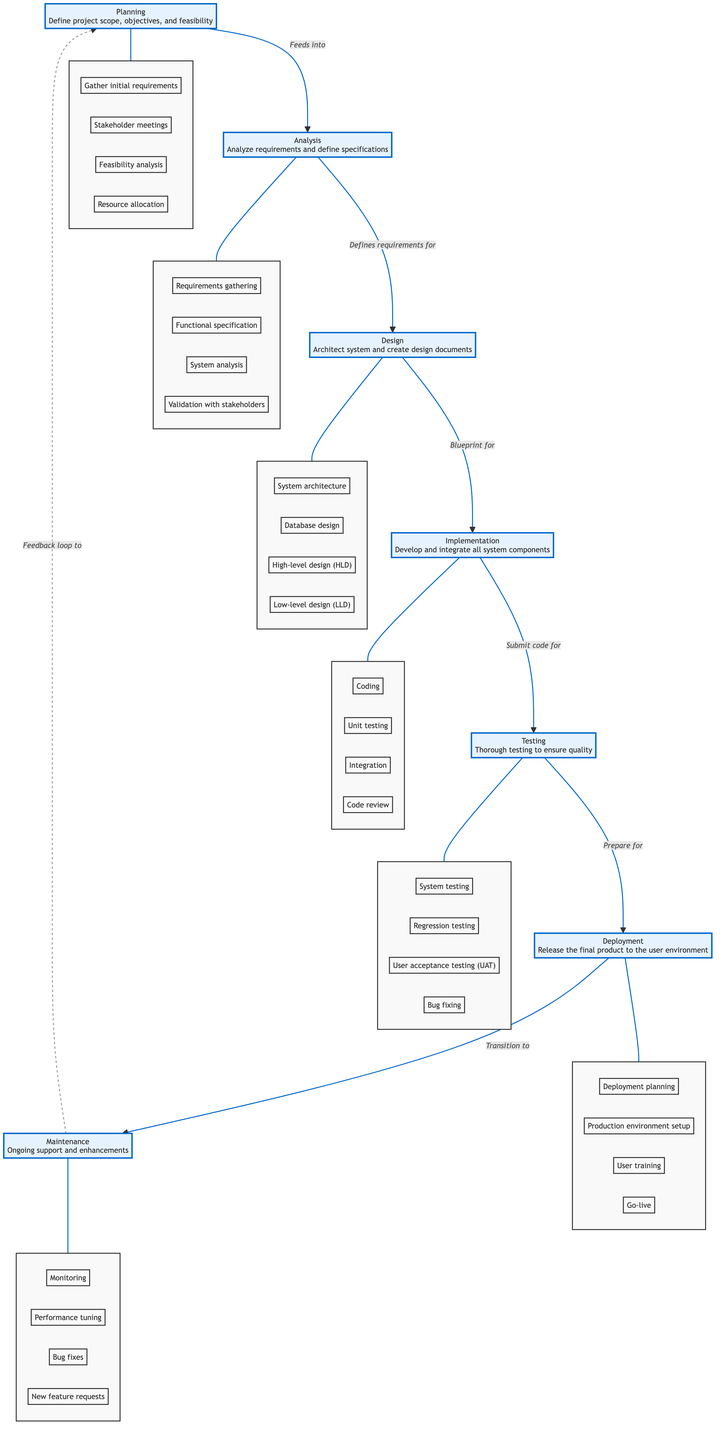What is the first phase of the Software Development Life Cycle? The diagram clearly identifies "Planning" as the first phase at the top, which is the starting point of the SDLC.
Answer: Planning How many total phases are there in the Software Development Life Cycle? By counting each of the labeled phases in the diagram, including Planning, Analysis, Design, Implementation, Testing, Deployment, and Maintenance, we find there are seven phases.
Answer: Seven Which phase comes after "Implementation"? The diagram shows an arrow from the "Implementation" phase pointing towards the "Testing" phase, indicating that Testing directly follows Implementation.
Answer: Testing What activity is included in the "Design" phase? In the breakdown of the "Design" phase, several specific activities are listed—one of them is "System architecture," which refers to one aspect of design work.
Answer: System architecture How does the "Deployment" phase relate to the "Testing" phase? The diagram illustrates that Testing prepares for Deployment, making it clear that Testing occurs before Deployment; hence, Deployment is dependent on Testing.
Answer: Precedes What is a feedback loop in the context of this diagram? The dashed line indicates a feedback loop from "Maintenance" back to "Planning," suggesting an iterative improvement process based on user feedback from Maintenance.
Answer: Maintenance to Planning What kind of testing is done during the "Testing" phase before deployment? The breakdown lists "User acceptance testing (UAT)" among other types of tests, indicating it is a key testing activity performed at this stage to ensure the software meets user expectations.
Answer: User acceptance testing Which phase involves resource allocation? The "Planning" phase includes the activity "Resource allocation," which is a critical step for ensuring that sufficient resources are available for the project delivery.
Answer: Resource allocation What establishes the specifications in the "Analysis" phase? The description of the "Analysis" phase states "Functional specification," which directly refers to the output that defines what the system must do based on the requirements.
Answer: Functional specification 